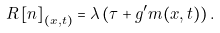<formula> <loc_0><loc_0><loc_500><loc_500>R \left [ n \right ] _ { ( x , t ) } = \lambda \left ( \tau + g ^ { \prime } m ( x , t ) \right ) .</formula> 